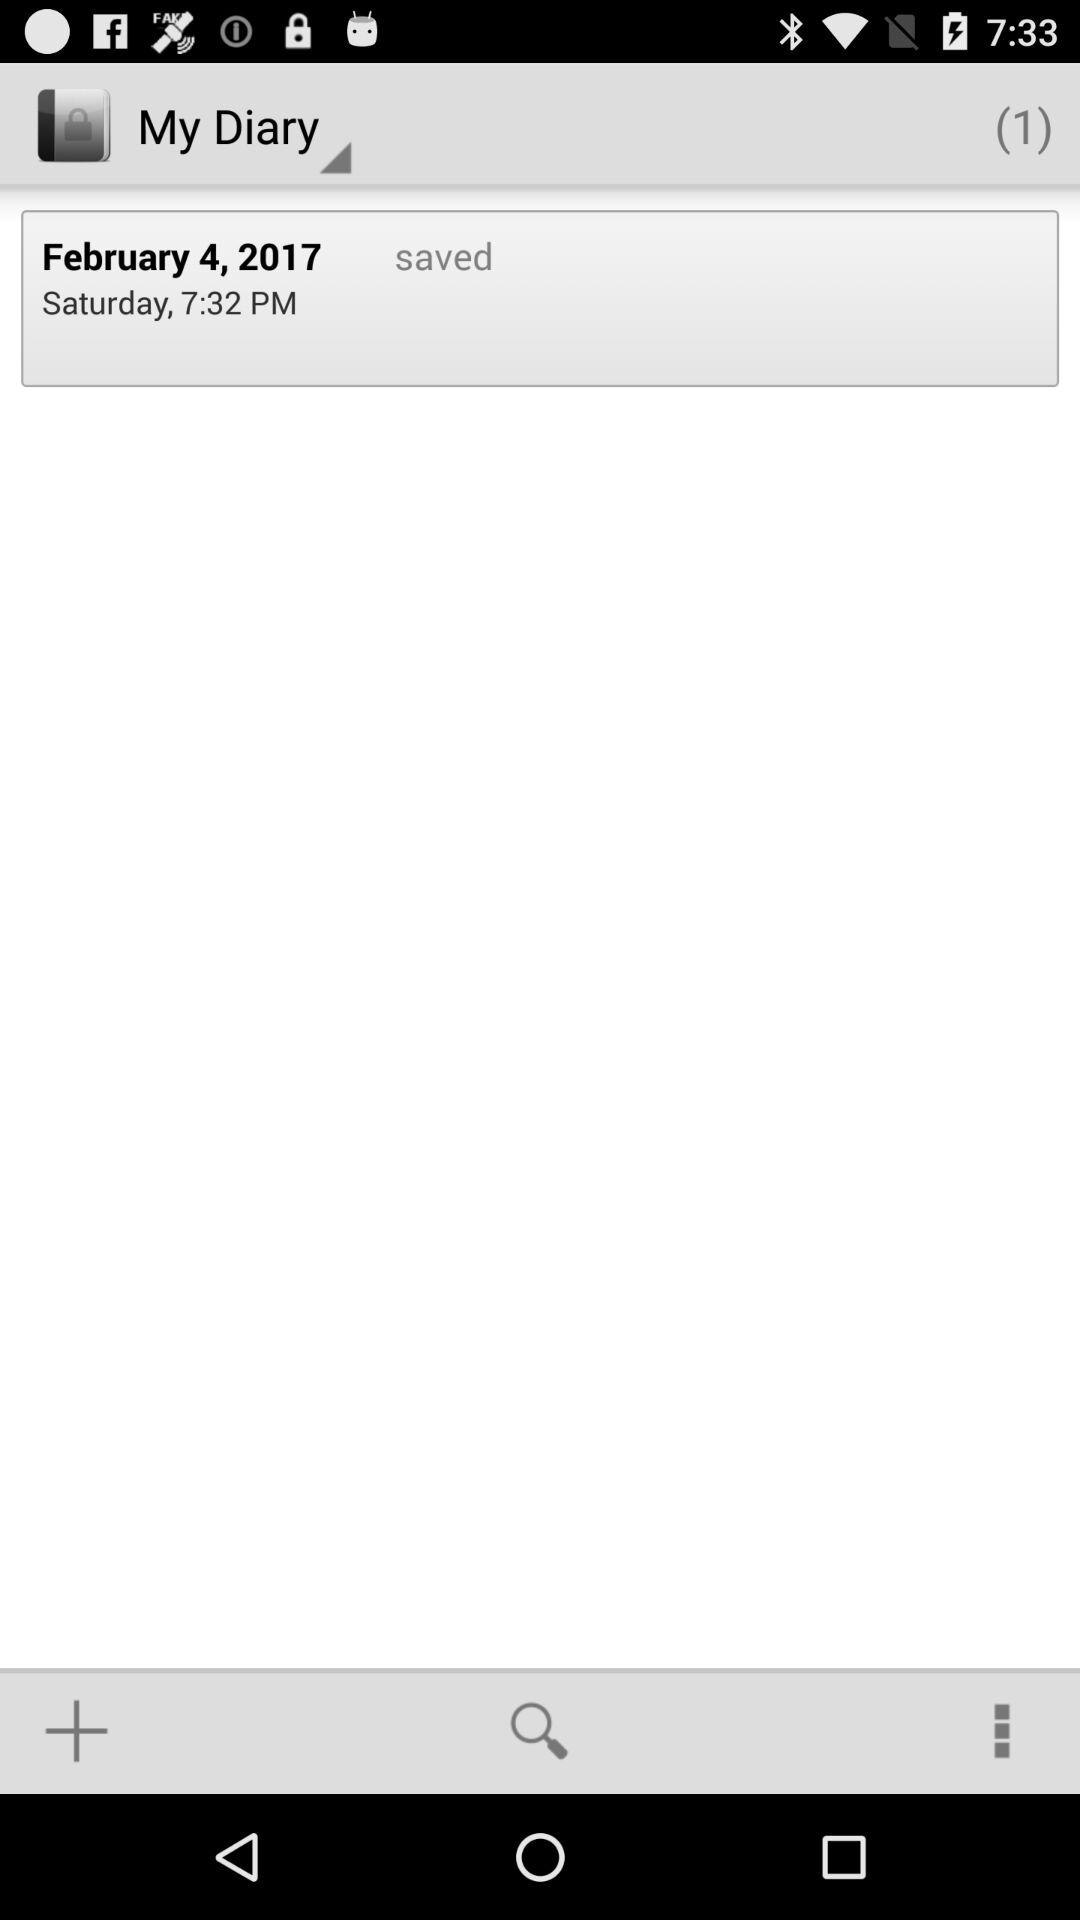How many notes are saved in "My Diary"? There is 1 note saved. 